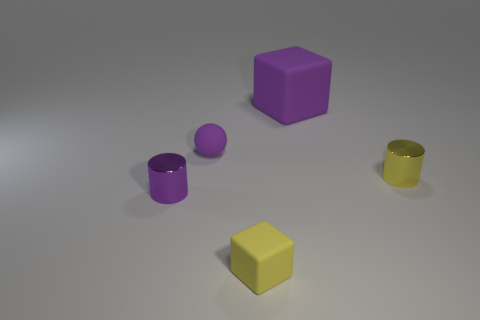What number of tiny cylinders are the same color as the small rubber block? There is one small cylinder that matches the color of the small rubber block, which is purple in color, aligning with your observation. 